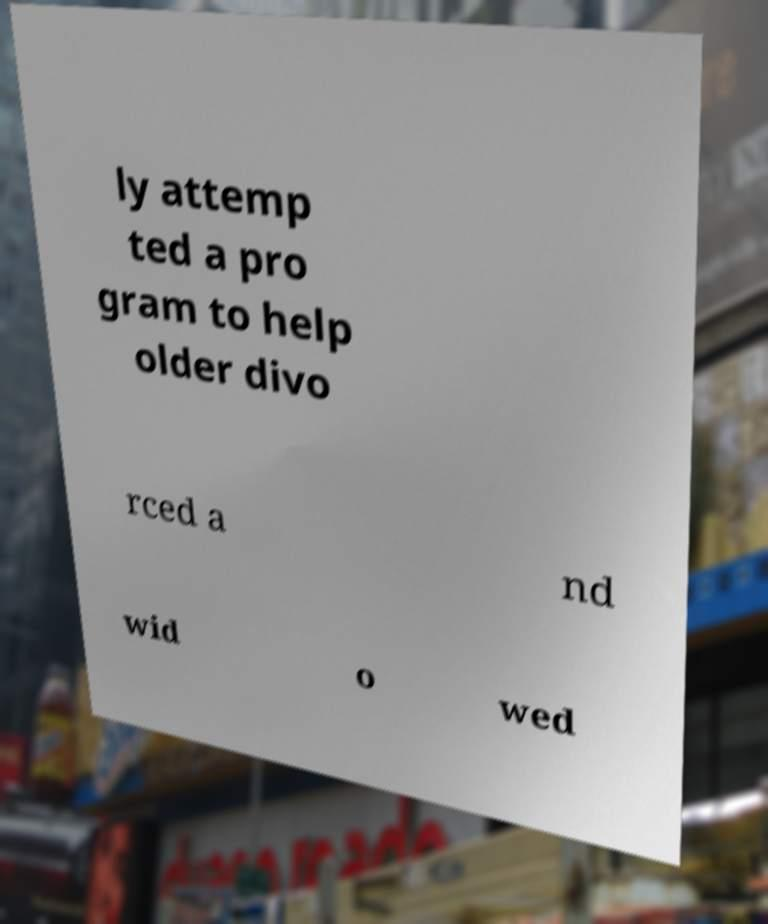Can you read and provide the text displayed in the image?This photo seems to have some interesting text. Can you extract and type it out for me? ly attemp ted a pro gram to help older divo rced a nd wid o wed 